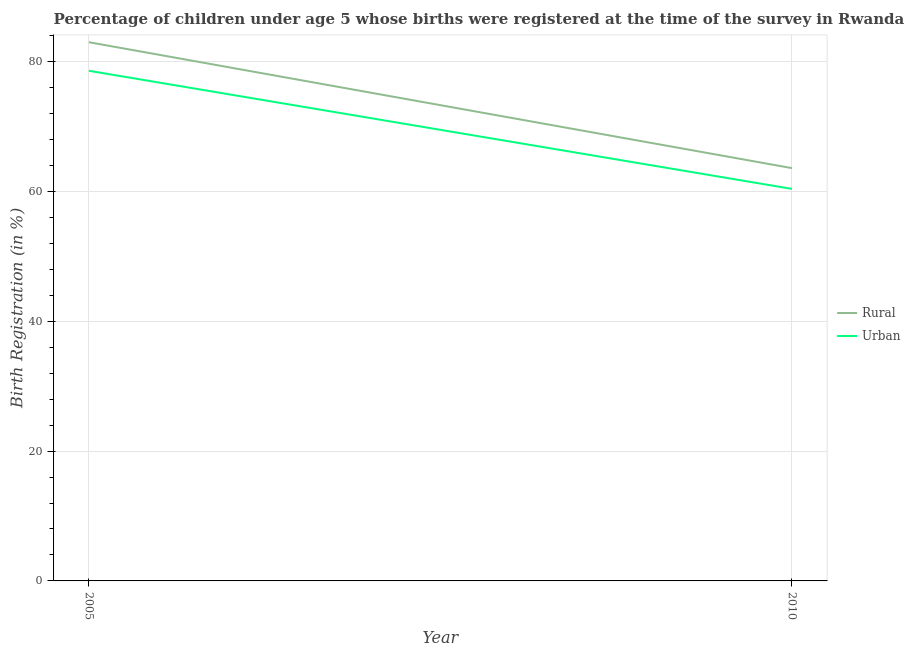How many different coloured lines are there?
Offer a terse response. 2. Does the line corresponding to rural birth registration intersect with the line corresponding to urban birth registration?
Provide a short and direct response. No. Is the number of lines equal to the number of legend labels?
Your response must be concise. Yes. What is the urban birth registration in 2010?
Your response must be concise. 60.4. Across all years, what is the maximum urban birth registration?
Offer a very short reply. 78.6. Across all years, what is the minimum rural birth registration?
Your response must be concise. 63.6. In which year was the rural birth registration minimum?
Your response must be concise. 2010. What is the total urban birth registration in the graph?
Make the answer very short. 139. What is the difference between the urban birth registration in 2010 and the rural birth registration in 2005?
Make the answer very short. -22.6. What is the average rural birth registration per year?
Keep it short and to the point. 73.3. In the year 2005, what is the difference between the rural birth registration and urban birth registration?
Provide a short and direct response. 4.4. In how many years, is the urban birth registration greater than 16 %?
Offer a very short reply. 2. What is the ratio of the urban birth registration in 2005 to that in 2010?
Your answer should be very brief. 1.3. Is the rural birth registration in 2005 less than that in 2010?
Give a very brief answer. No. Does the urban birth registration monotonically increase over the years?
Provide a succinct answer. No. Is the rural birth registration strictly less than the urban birth registration over the years?
Provide a short and direct response. No. How many lines are there?
Ensure brevity in your answer.  2. Are the values on the major ticks of Y-axis written in scientific E-notation?
Offer a very short reply. No. Does the graph contain any zero values?
Give a very brief answer. No. Does the graph contain grids?
Provide a succinct answer. Yes. What is the title of the graph?
Your response must be concise. Percentage of children under age 5 whose births were registered at the time of the survey in Rwanda. Does "Urban Population" appear as one of the legend labels in the graph?
Ensure brevity in your answer.  No. What is the label or title of the X-axis?
Your response must be concise. Year. What is the label or title of the Y-axis?
Provide a succinct answer. Birth Registration (in %). What is the Birth Registration (in %) of Urban in 2005?
Make the answer very short. 78.6. What is the Birth Registration (in %) of Rural in 2010?
Your answer should be compact. 63.6. What is the Birth Registration (in %) of Urban in 2010?
Offer a very short reply. 60.4. Across all years, what is the maximum Birth Registration (in %) in Urban?
Provide a succinct answer. 78.6. Across all years, what is the minimum Birth Registration (in %) of Rural?
Keep it short and to the point. 63.6. Across all years, what is the minimum Birth Registration (in %) in Urban?
Make the answer very short. 60.4. What is the total Birth Registration (in %) of Rural in the graph?
Give a very brief answer. 146.6. What is the total Birth Registration (in %) in Urban in the graph?
Ensure brevity in your answer.  139. What is the difference between the Birth Registration (in %) in Rural in 2005 and the Birth Registration (in %) in Urban in 2010?
Provide a short and direct response. 22.6. What is the average Birth Registration (in %) in Rural per year?
Offer a very short reply. 73.3. What is the average Birth Registration (in %) in Urban per year?
Your answer should be compact. 69.5. In the year 2005, what is the difference between the Birth Registration (in %) in Rural and Birth Registration (in %) in Urban?
Offer a very short reply. 4.4. In the year 2010, what is the difference between the Birth Registration (in %) in Rural and Birth Registration (in %) in Urban?
Offer a terse response. 3.2. What is the ratio of the Birth Registration (in %) in Rural in 2005 to that in 2010?
Your response must be concise. 1.3. What is the ratio of the Birth Registration (in %) in Urban in 2005 to that in 2010?
Your answer should be compact. 1.3. What is the difference between the highest and the second highest Birth Registration (in %) of Rural?
Your answer should be compact. 19.4. What is the difference between the highest and the second highest Birth Registration (in %) of Urban?
Ensure brevity in your answer.  18.2. What is the difference between the highest and the lowest Birth Registration (in %) in Rural?
Your answer should be compact. 19.4. 